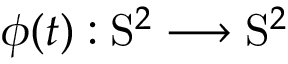Convert formula to latex. <formula><loc_0><loc_0><loc_500><loc_500>\phi ( t ) \colon S ^ { 2 } \longrightarrow S ^ { 2 }</formula> 